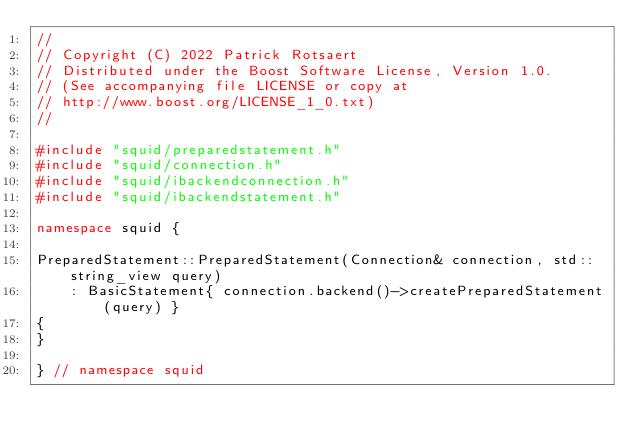<code> <loc_0><loc_0><loc_500><loc_500><_C++_>//
// Copyright (C) 2022 Patrick Rotsaert
// Distributed under the Boost Software License, Version 1.0.
// (See accompanying file LICENSE or copy at
// http://www.boost.org/LICENSE_1_0.txt)
//

#include "squid/preparedstatement.h"
#include "squid/connection.h"
#include "squid/ibackendconnection.h"
#include "squid/ibackendstatement.h"

namespace squid {

PreparedStatement::PreparedStatement(Connection& connection, std::string_view query)
    : BasicStatement{ connection.backend()->createPreparedStatement(query) }
{
}

} // namespace squid
</code> 